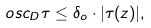<formula> <loc_0><loc_0><loc_500><loc_500>o s c _ { D } \tau \leq \delta _ { o } \cdot | \tau ( z ) | ,</formula> 